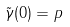<formula> <loc_0><loc_0><loc_500><loc_500>\tilde { \gamma } ( 0 ) = p</formula> 